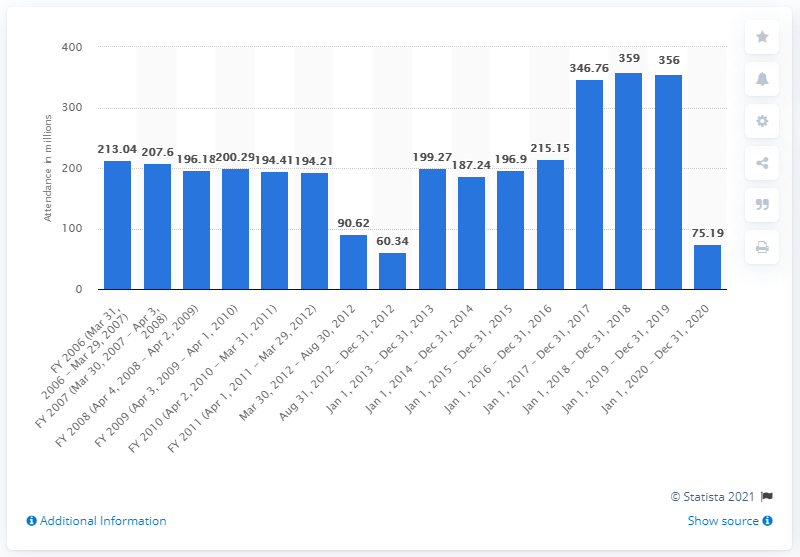Highlight a few significant elements in this photo. A total of 75,190 people attended AMC movie theaters in fiscal year 2020. In 2017, the total attendance of AMC movie theaters was 346,760. 